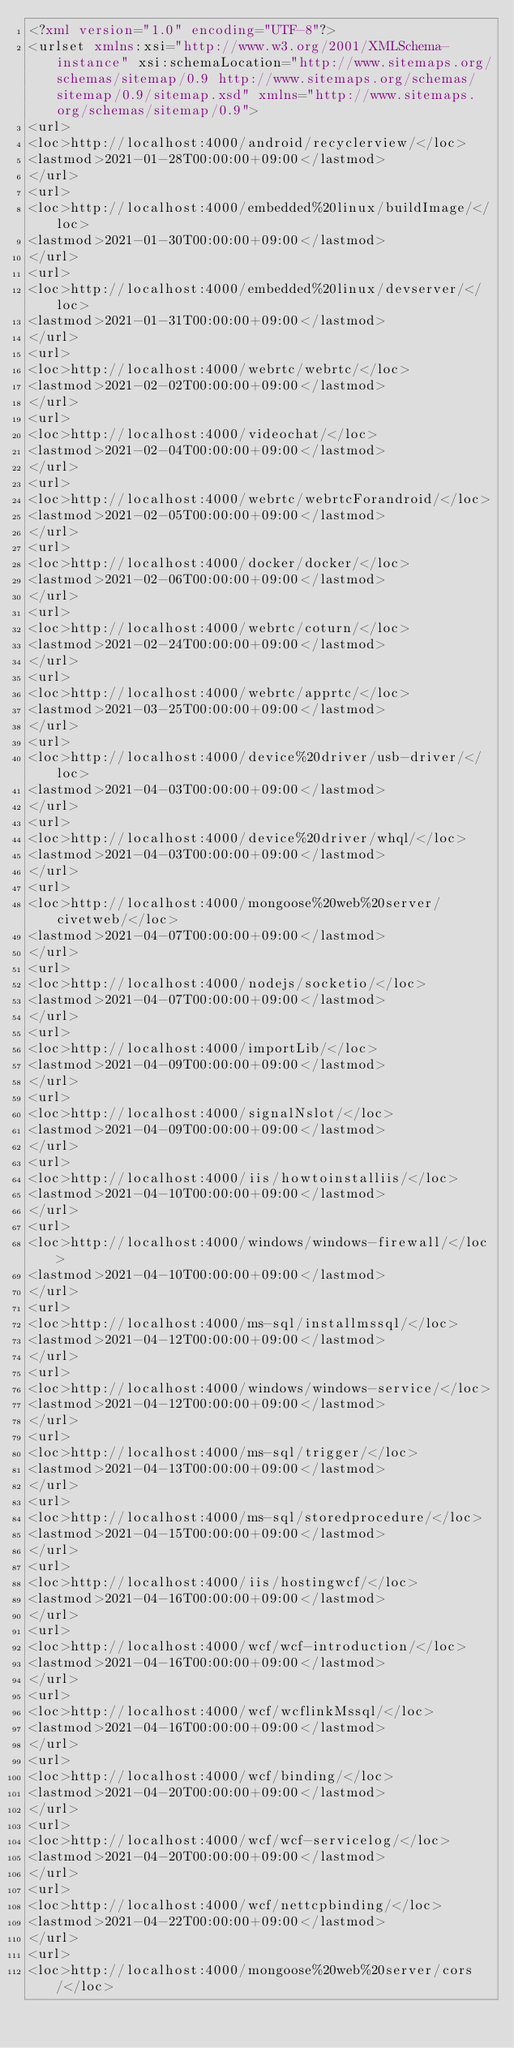Convert code to text. <code><loc_0><loc_0><loc_500><loc_500><_XML_><?xml version="1.0" encoding="UTF-8"?>
<urlset xmlns:xsi="http://www.w3.org/2001/XMLSchema-instance" xsi:schemaLocation="http://www.sitemaps.org/schemas/sitemap/0.9 http://www.sitemaps.org/schemas/sitemap/0.9/sitemap.xsd" xmlns="http://www.sitemaps.org/schemas/sitemap/0.9">
<url>
<loc>http://localhost:4000/android/recyclerview/</loc>
<lastmod>2021-01-28T00:00:00+09:00</lastmod>
</url>
<url>
<loc>http://localhost:4000/embedded%20linux/buildImage/</loc>
<lastmod>2021-01-30T00:00:00+09:00</lastmod>
</url>
<url>
<loc>http://localhost:4000/embedded%20linux/devserver/</loc>
<lastmod>2021-01-31T00:00:00+09:00</lastmod>
</url>
<url>
<loc>http://localhost:4000/webrtc/webrtc/</loc>
<lastmod>2021-02-02T00:00:00+09:00</lastmod>
</url>
<url>
<loc>http://localhost:4000/videochat/</loc>
<lastmod>2021-02-04T00:00:00+09:00</lastmod>
</url>
<url>
<loc>http://localhost:4000/webrtc/webrtcForandroid/</loc>
<lastmod>2021-02-05T00:00:00+09:00</lastmod>
</url>
<url>
<loc>http://localhost:4000/docker/docker/</loc>
<lastmod>2021-02-06T00:00:00+09:00</lastmod>
</url>
<url>
<loc>http://localhost:4000/webrtc/coturn/</loc>
<lastmod>2021-02-24T00:00:00+09:00</lastmod>
</url>
<url>
<loc>http://localhost:4000/webrtc/apprtc/</loc>
<lastmod>2021-03-25T00:00:00+09:00</lastmod>
</url>
<url>
<loc>http://localhost:4000/device%20driver/usb-driver/</loc>
<lastmod>2021-04-03T00:00:00+09:00</lastmod>
</url>
<url>
<loc>http://localhost:4000/device%20driver/whql/</loc>
<lastmod>2021-04-03T00:00:00+09:00</lastmod>
</url>
<url>
<loc>http://localhost:4000/mongoose%20web%20server/civetweb/</loc>
<lastmod>2021-04-07T00:00:00+09:00</lastmod>
</url>
<url>
<loc>http://localhost:4000/nodejs/socketio/</loc>
<lastmod>2021-04-07T00:00:00+09:00</lastmod>
</url>
<url>
<loc>http://localhost:4000/importLib/</loc>
<lastmod>2021-04-09T00:00:00+09:00</lastmod>
</url>
<url>
<loc>http://localhost:4000/signalNslot/</loc>
<lastmod>2021-04-09T00:00:00+09:00</lastmod>
</url>
<url>
<loc>http://localhost:4000/iis/howtoinstalliis/</loc>
<lastmod>2021-04-10T00:00:00+09:00</lastmod>
</url>
<url>
<loc>http://localhost:4000/windows/windows-firewall/</loc>
<lastmod>2021-04-10T00:00:00+09:00</lastmod>
</url>
<url>
<loc>http://localhost:4000/ms-sql/installmssql/</loc>
<lastmod>2021-04-12T00:00:00+09:00</lastmod>
</url>
<url>
<loc>http://localhost:4000/windows/windows-service/</loc>
<lastmod>2021-04-12T00:00:00+09:00</lastmod>
</url>
<url>
<loc>http://localhost:4000/ms-sql/trigger/</loc>
<lastmod>2021-04-13T00:00:00+09:00</lastmod>
</url>
<url>
<loc>http://localhost:4000/ms-sql/storedprocedure/</loc>
<lastmod>2021-04-15T00:00:00+09:00</lastmod>
</url>
<url>
<loc>http://localhost:4000/iis/hostingwcf/</loc>
<lastmod>2021-04-16T00:00:00+09:00</lastmod>
</url>
<url>
<loc>http://localhost:4000/wcf/wcf-introduction/</loc>
<lastmod>2021-04-16T00:00:00+09:00</lastmod>
</url>
<url>
<loc>http://localhost:4000/wcf/wcflinkMssql/</loc>
<lastmod>2021-04-16T00:00:00+09:00</lastmod>
</url>
<url>
<loc>http://localhost:4000/wcf/binding/</loc>
<lastmod>2021-04-20T00:00:00+09:00</lastmod>
</url>
<url>
<loc>http://localhost:4000/wcf/wcf-servicelog/</loc>
<lastmod>2021-04-20T00:00:00+09:00</lastmod>
</url>
<url>
<loc>http://localhost:4000/wcf/nettcpbinding/</loc>
<lastmod>2021-04-22T00:00:00+09:00</lastmod>
</url>
<url>
<loc>http://localhost:4000/mongoose%20web%20server/cors/</loc></code> 